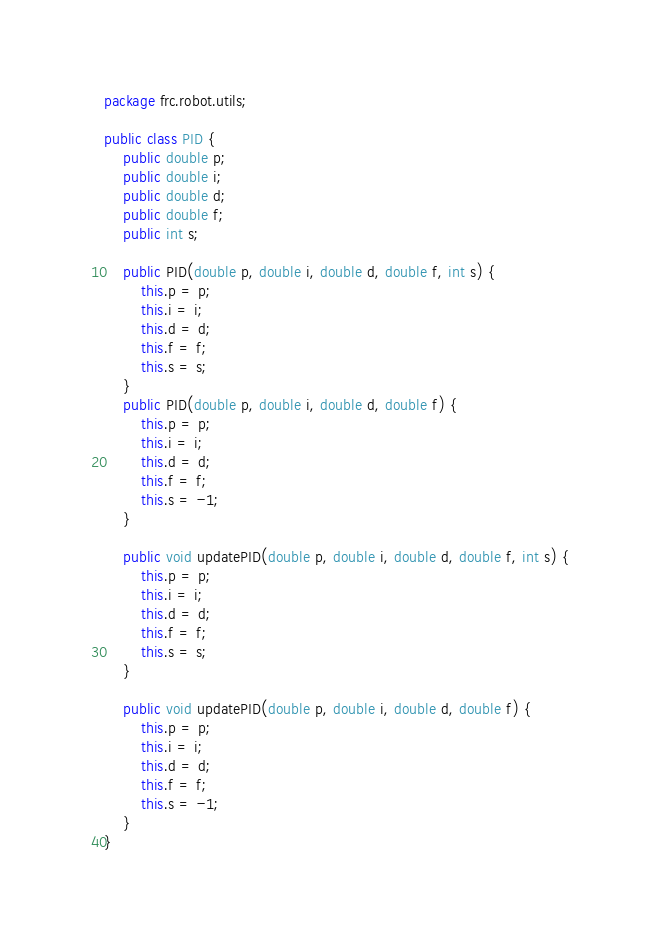Convert code to text. <code><loc_0><loc_0><loc_500><loc_500><_Java_>package frc.robot.utils;

public class PID {
    public double p;
    public double i;
    public double d;
    public double f;
    public int s;

    public PID(double p, double i, double d, double f, int s) {
        this.p = p;
        this.i = i;
        this.d = d;
        this.f = f;
        this.s = s;
    }
    public PID(double p, double i, double d, double f) {
        this.p = p;
        this.i = i;
        this.d = d;
        this.f = f;
        this.s = -1;
    }

    public void updatePID(double p, double i, double d, double f, int s) {
        this.p = p;
        this.i = i;
        this.d = d;
        this.f = f;
        this.s = s;
    }

    public void updatePID(double p, double i, double d, double f) {
        this.p = p;
        this.i = i;
        this.d = d;
        this.f = f;
        this.s = -1;
    }
}</code> 